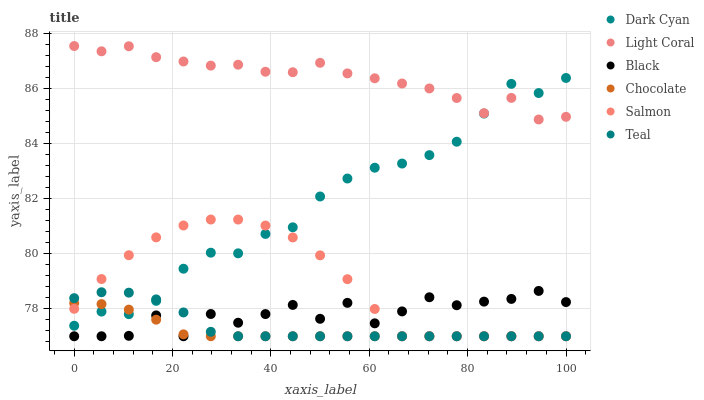Does Chocolate have the minimum area under the curve?
Answer yes or no. Yes. Does Light Coral have the maximum area under the curve?
Answer yes or no. Yes. Does Light Coral have the minimum area under the curve?
Answer yes or no. No. Does Chocolate have the maximum area under the curve?
Answer yes or no. No. Is Chocolate the smoothest?
Answer yes or no. Yes. Is Black the roughest?
Answer yes or no. Yes. Is Light Coral the smoothest?
Answer yes or no. No. Is Light Coral the roughest?
Answer yes or no. No. Does Salmon have the lowest value?
Answer yes or no. Yes. Does Light Coral have the lowest value?
Answer yes or no. No. Does Light Coral have the highest value?
Answer yes or no. Yes. Does Chocolate have the highest value?
Answer yes or no. No. Is Black less than Dark Cyan?
Answer yes or no. Yes. Is Light Coral greater than Black?
Answer yes or no. Yes. Does Chocolate intersect Black?
Answer yes or no. Yes. Is Chocolate less than Black?
Answer yes or no. No. Is Chocolate greater than Black?
Answer yes or no. No. Does Black intersect Dark Cyan?
Answer yes or no. No. 